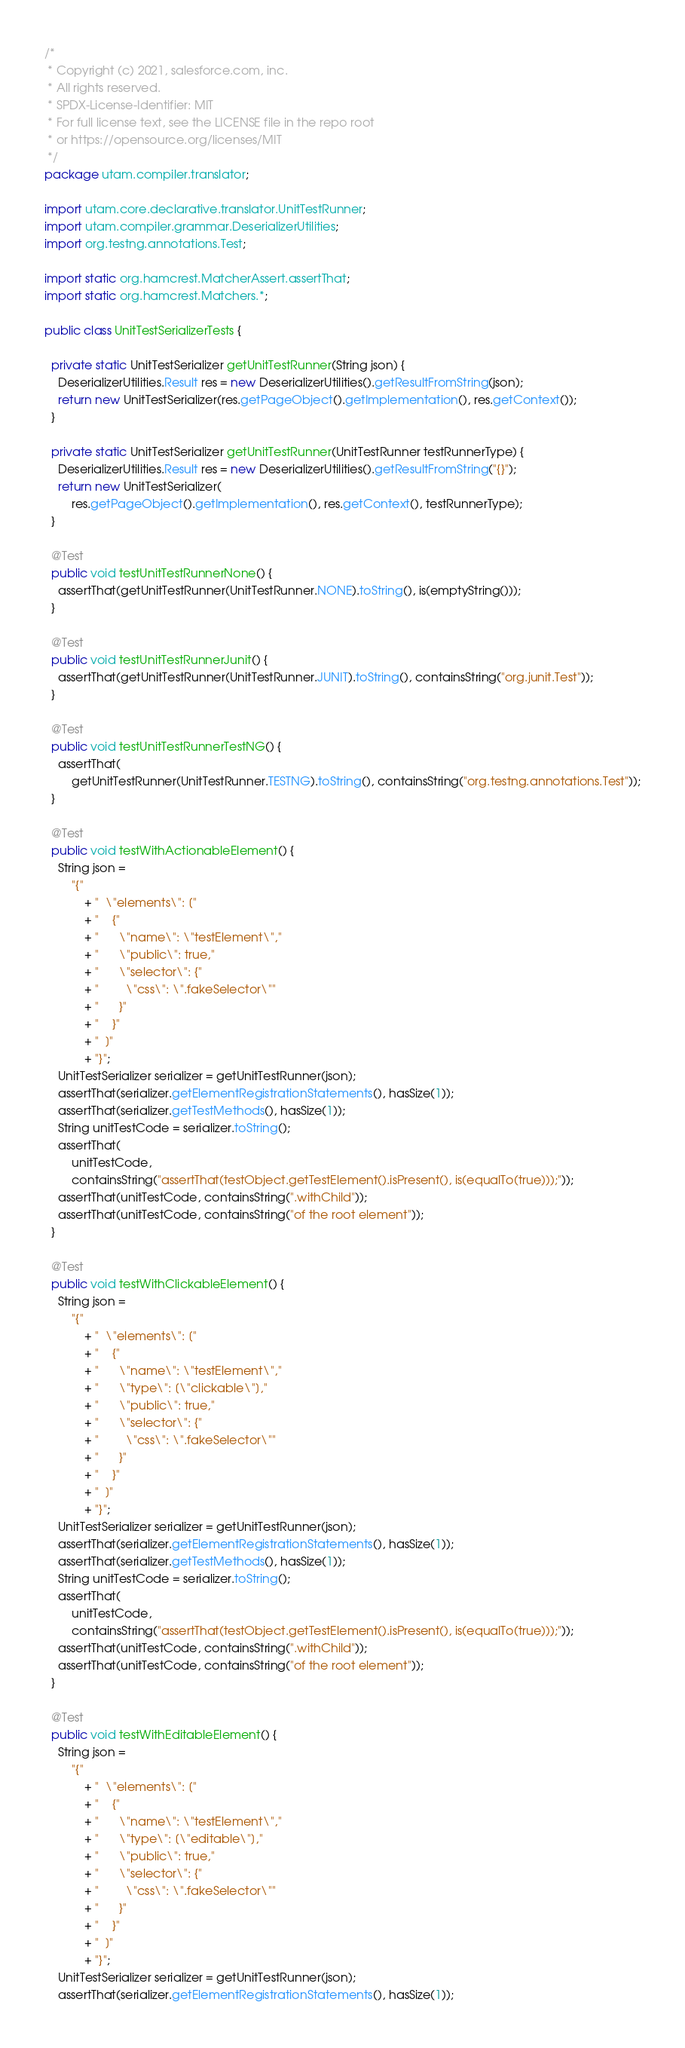<code> <loc_0><loc_0><loc_500><loc_500><_Java_>/*
 * Copyright (c) 2021, salesforce.com, inc.
 * All rights reserved.
 * SPDX-License-Identifier: MIT
 * For full license text, see the LICENSE file in the repo root
 * or https://opensource.org/licenses/MIT
 */
package utam.compiler.translator;

import utam.core.declarative.translator.UnitTestRunner;
import utam.compiler.grammar.DeserializerUtilities;
import org.testng.annotations.Test;

import static org.hamcrest.MatcherAssert.assertThat;
import static org.hamcrest.Matchers.*;

public class UnitTestSerializerTests {

  private static UnitTestSerializer getUnitTestRunner(String json) {
    DeserializerUtilities.Result res = new DeserializerUtilities().getResultFromString(json);
    return new UnitTestSerializer(res.getPageObject().getImplementation(), res.getContext());
  }

  private static UnitTestSerializer getUnitTestRunner(UnitTestRunner testRunnerType) {
    DeserializerUtilities.Result res = new DeserializerUtilities().getResultFromString("{}");
    return new UnitTestSerializer(
        res.getPageObject().getImplementation(), res.getContext(), testRunnerType);
  }

  @Test
  public void testUnitTestRunnerNone() {
    assertThat(getUnitTestRunner(UnitTestRunner.NONE).toString(), is(emptyString()));
  }

  @Test
  public void testUnitTestRunnerJunit() {
    assertThat(getUnitTestRunner(UnitTestRunner.JUNIT).toString(), containsString("org.junit.Test"));
  }

  @Test
  public void testUnitTestRunnerTestNG() {
    assertThat(
        getUnitTestRunner(UnitTestRunner.TESTNG).toString(), containsString("org.testng.annotations.Test"));
  }

  @Test
  public void testWithActionableElement() {
    String json =
        "{"
            + "  \"elements\": ["
            + "    {"
            + "      \"name\": \"testElement\","
            + "      \"public\": true,"
            + "      \"selector\": {"
            + "        \"css\": \".fakeSelector\""
            + "      }"
            + "    }"
            + "  ]"
            + "}";
    UnitTestSerializer serializer = getUnitTestRunner(json);
    assertThat(serializer.getElementRegistrationStatements(), hasSize(1));
    assertThat(serializer.getTestMethods(), hasSize(1));
    String unitTestCode = serializer.toString();
    assertThat(
        unitTestCode,
        containsString("assertThat(testObject.getTestElement().isPresent(), is(equalTo(true)));"));
    assertThat(unitTestCode, containsString(".withChild"));
    assertThat(unitTestCode, containsString("of the root element"));
  }

  @Test
  public void testWithClickableElement() {
    String json =
        "{"
            + "  \"elements\": ["
            + "    {"
            + "      \"name\": \"testElement\","
            + "      \"type\": [\"clickable\"],"
            + "      \"public\": true,"
            + "      \"selector\": {"
            + "        \"css\": \".fakeSelector\""
            + "      }"
            + "    }"
            + "  ]"
            + "}";
    UnitTestSerializer serializer = getUnitTestRunner(json);
    assertThat(serializer.getElementRegistrationStatements(), hasSize(1));
    assertThat(serializer.getTestMethods(), hasSize(1));
    String unitTestCode = serializer.toString();
    assertThat(
        unitTestCode,
        containsString("assertThat(testObject.getTestElement().isPresent(), is(equalTo(true)));"));
    assertThat(unitTestCode, containsString(".withChild"));
    assertThat(unitTestCode, containsString("of the root element"));
  }

  @Test
  public void testWithEditableElement() {
    String json =
        "{"
            + "  \"elements\": ["
            + "    {"
            + "      \"name\": \"testElement\","
            + "      \"type\": [\"editable\"],"
            + "      \"public\": true,"
            + "      \"selector\": {"
            + "        \"css\": \".fakeSelector\""
            + "      }"
            + "    }"
            + "  ]"
            + "}";
    UnitTestSerializer serializer = getUnitTestRunner(json);
    assertThat(serializer.getElementRegistrationStatements(), hasSize(1));</code> 